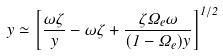Convert formula to latex. <formula><loc_0><loc_0><loc_500><loc_500>\dot { y } \simeq \left [ \frac { \omega \zeta } { y } - \omega \zeta + \frac { \zeta \Omega _ { e } \omega } { ( 1 - \Omega _ { e } ) y } \right ] ^ { 1 / 2 }</formula> 